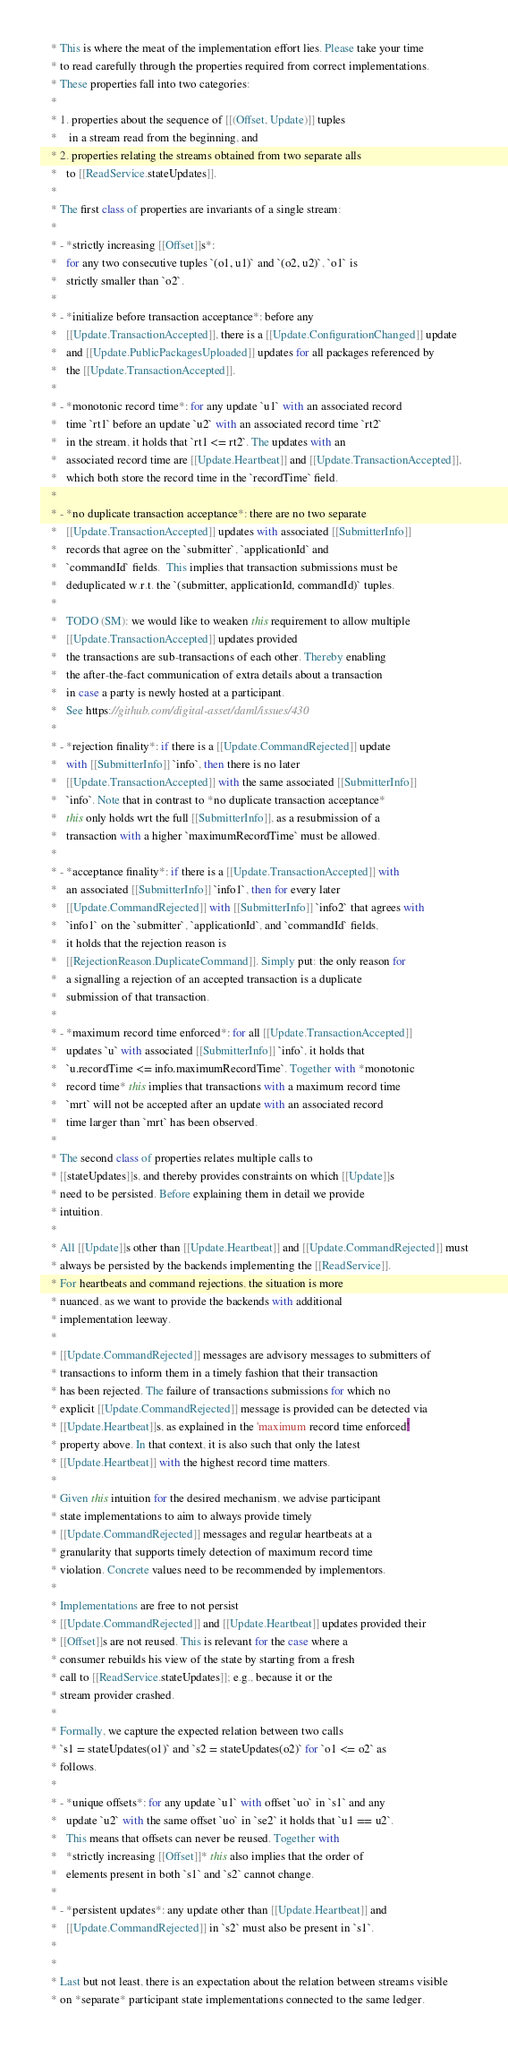<code> <loc_0><loc_0><loc_500><loc_500><_Scala_>    * This is where the meat of the implementation effort lies. Please take your time
    * to read carefully through the properties required from correct implementations.
    * These properties fall into two categories:
    *
    * 1. properties about the sequence of [[(Offset, Update)]] tuples
    *    in a stream read from the beginning, and
    * 2. properties relating the streams obtained from two separate alls
    *   to [[ReadService.stateUpdates]].
    *
    * The first class of properties are invariants of a single stream:
    *
    * - *strictly increasing [[Offset]]s*:
    *   for any two consecutive tuples `(o1, u1)` and `(o2, u2)`, `o1` is
    *   strictly smaller than `o2`.
    *
    * - *initialize before transaction acceptance*: before any
    *   [[Update.TransactionAccepted]], there is a [[Update.ConfigurationChanged]] update
    *   and [[Update.PublicPackagesUploaded]] updates for all packages referenced by
    *   the [[Update.TransactionAccepted]].
    *
    * - *monotonic record time*: for any update `u1` with an associated record
    *   time `rt1` before an update `u2` with an associated record time `rt2`
    *   in the stream, it holds that `rt1 <= rt2`. The updates with an
    *   associated record time are [[Update.Heartbeat]] and [[Update.TransactionAccepted]],
    *   which both store the record time in the `recordTime` field.
    *
    * - *no duplicate transaction acceptance*: there are no two separate
    *   [[Update.TransactionAccepted]] updates with associated [[SubmitterInfo]]
    *   records that agree on the `submitter`, `applicationId` and
    *   `commandId` fields.  This implies that transaction submissions must be
    *   deduplicated w.r.t. the `(submitter, applicationId, commandId)` tuples.
    *
    *   TODO (SM): we would like to weaken this requirement to allow multiple
    *   [[Update.TransactionAccepted]] updates provided
    *   the transactions are sub-transactions of each other. Thereby enabling
    *   the after-the-fact communication of extra details about a transaction
    *   in case a party is newly hosted at a participant.
    *   See https://github.com/digital-asset/daml/issues/430
    *
    * - *rejection finality*: if there is a [[Update.CommandRejected]] update
    *   with [[SubmitterInfo]] `info`, then there is no later
    *   [[Update.TransactionAccepted]] with the same associated [[SubmitterInfo]]
    *   `info`. Note that in contrast to *no duplicate transaction acceptance*
    *   this only holds wrt the full [[SubmitterInfo]], as a resubmission of a
    *   transaction with a higher `maximumRecordTime` must be allowed.
    *
    * - *acceptance finality*: if there is a [[Update.TransactionAccepted]] with
    *   an associated [[SubmitterInfo]] `info1`, then for every later
    *   [[Update.CommandRejected]] with [[SubmitterInfo]] `info2` that agrees with
    *   `info1` on the `submitter`, `applicationId`, and `commandId` fields,
    *   it holds that the rejection reason is
    *   [[RejectionReason.DuplicateCommand]]. Simply put: the only reason for
    *   a signalling a rejection of an accepted transaction is a duplicate
    *   submission of that transaction.
    *
    * - *maximum record time enforced*: for all [[Update.TransactionAccepted]]
    *   updates `u` with associated [[SubmitterInfo]] `info`, it holds that
    *   `u.recordTime <= info.maximumRecordTime`. Together with *monotonic
    *   record time* this implies that transactions with a maximum record time
    *   `mrt` will not be accepted after an update with an associated record
    *   time larger than `mrt` has been observed.
    *
    * The second class of properties relates multiple calls to
    * [[stateUpdates]]s, and thereby provides constraints on which [[Update]]s
    * need to be persisted. Before explaining them in detail we provide
    * intuition.
    *
    * All [[Update]]s other than [[Update.Heartbeat]] and [[Update.CommandRejected]] must
    * always be persisted by the backends implementing the [[ReadService]].
    * For heartbeats and command rejections, the situation is more
    * nuanced, as we want to provide the backends with additional
    * implementation leeway.
    *
    * [[Update.CommandRejected]] messages are advisory messages to submitters of
    * transactions to inform them in a timely fashion that their transaction
    * has been rejected. The failure of transactions submissions for which no
    * explicit [[Update.CommandRejected]] message is provided can be detected via
    * [[Update.Heartbeat]]s, as explained in the 'maximum record time enforced'
    * property above. In that context, it is also such that only the latest
    * [[Update.Heartbeat]] with the highest record time matters.
    *
    * Given this intuition for the desired mechanism, we advise participant
    * state implementations to aim to always provide timely
    * [[Update.CommandRejected]] messages and regular heartbeats at a
    * granularity that supports timely detection of maximum record time
    * violation. Concrete values need to be recommended by implementors.
    *
    * Implementations are free to not persist
    * [[Update.CommandRejected]] and [[Update.Heartbeat]] updates provided their
    * [[Offset]]s are not reused. This is relevant for the case where a
    * consumer rebuilds his view of the state by starting from a fresh
    * call to [[ReadService.stateUpdates]]; e.g., because it or the
    * stream provider crashed.
    *
    * Formally, we capture the expected relation between two calls
    * `s1 = stateUpdates(o1)` and `s2 = stateUpdates(o2)` for `o1 <= o2` as
    * follows.
    *
    * - *unique offsets*: for any update `u1` with offset `uo` in `s1` and any
    *   update `u2` with the same offset `uo` in `se2` it holds that `u1 == u2`.
    *   This means that offsets can never be reused. Together with
    *   *strictly increasing [[Offset]]* this also implies that the order of
    *   elements present in both `s1` and `s2` cannot change.
    *
    * - *persistent updates*: any update other than [[Update.Heartbeat]] and
    *   [[Update.CommandRejected]] in `s2` must also be present in `s1`.
    *
    *
    * Last but not least, there is an expectation about the relation between streams visible
    * on *separate* participant state implementations connected to the same ledger.</code> 